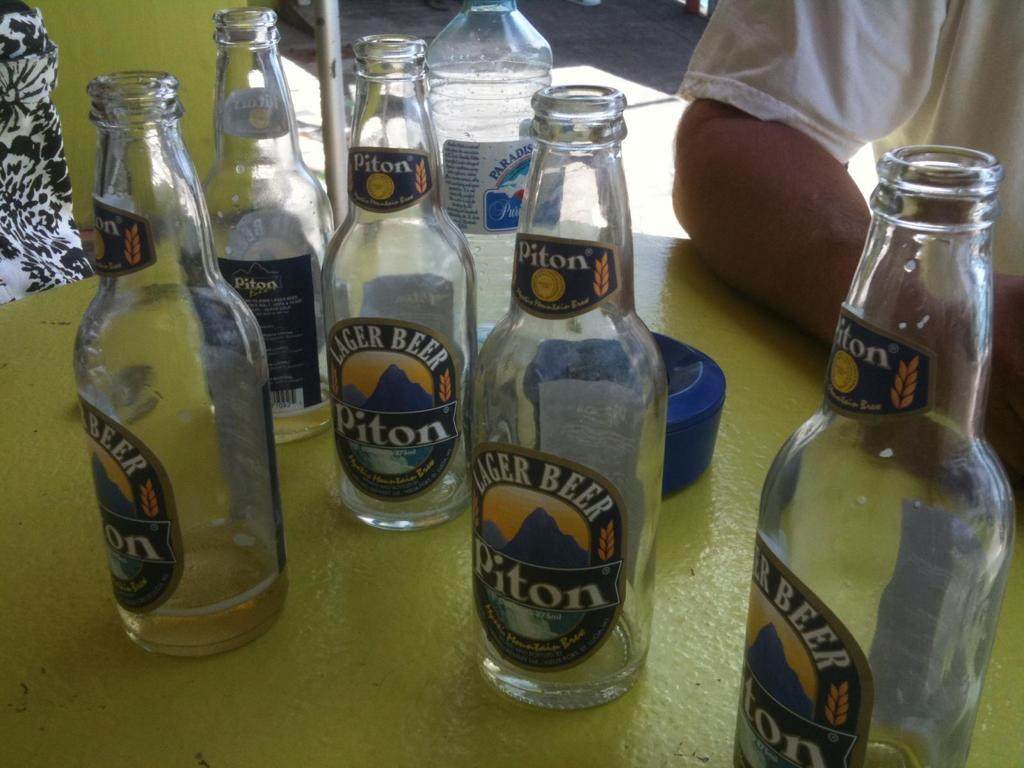<image>
Create a compact narrative representing the image presented. 5 empty bottles of Piton Lager Beer sitting on a table. 